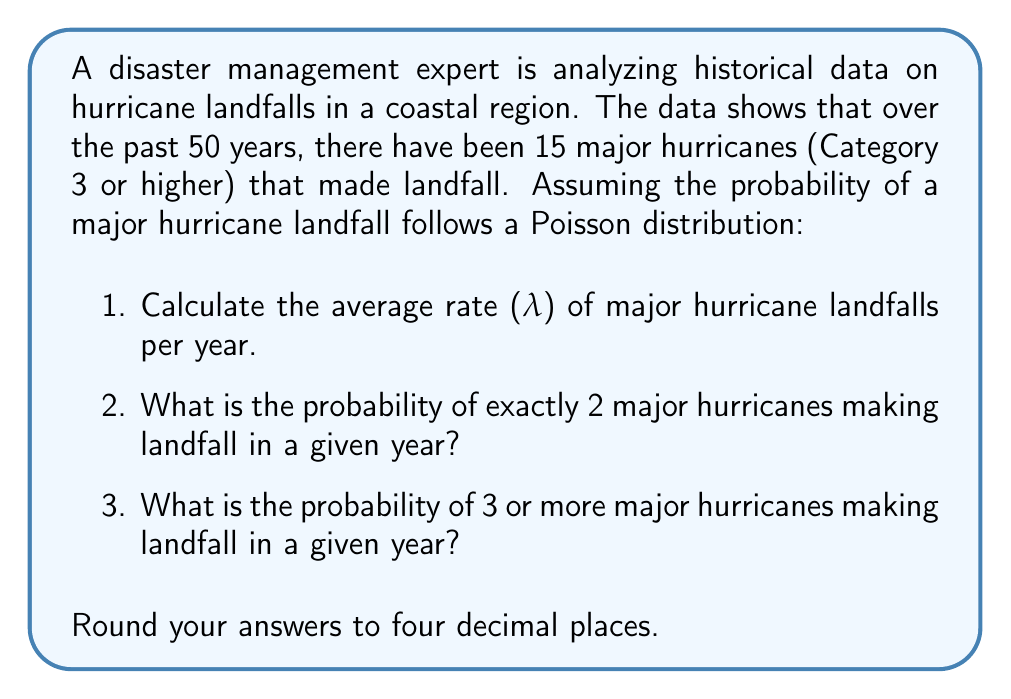Could you help me with this problem? 1. To calculate the average rate (λ) of major hurricane landfalls per year:
   λ = Total number of events / Number of years
   λ = 15 / 50 = 0.3 major hurricanes per year

2. To find the probability of exactly 2 major hurricanes in a year, we use the Poisson probability mass function:
   $$P(X = k) = \frac{e^{-λ} λ^k}{k!}$$
   Where X is the number of events, k is the specific number we're interested in, e is Euler's number, and λ is the average rate.

   $$P(X = 2) = \frac{e^{-0.3} (0.3)^2}{2!}$$
   
   $$= \frac{0.7408 \times 0.09}{2} = 0.0333$$

3. To find the probability of 3 or more major hurricanes, we can subtract the probabilities of 0, 1, and 2 hurricanes from 1:

   $$P(X ≥ 3) = 1 - [P(X = 0) + P(X = 1) + P(X = 2)]$$

   $$P(X = 0) = \frac{e^{-0.3} (0.3)^0}{0!} = 0.7408$$

   $$P(X = 1) = \frac{e^{-0.3} (0.3)^1}{1!} = 0.2222$$

   $$P(X = 2) = 0.0333$$ (calculated earlier)

   $$P(X ≥ 3) = 1 - (0.7408 + 0.2222 + 0.0333) = 0.0037$$
Answer: 1. λ = 0.3
2. P(X = 2) = 0.0333
3. P(X ≥ 3) = 0.0037 